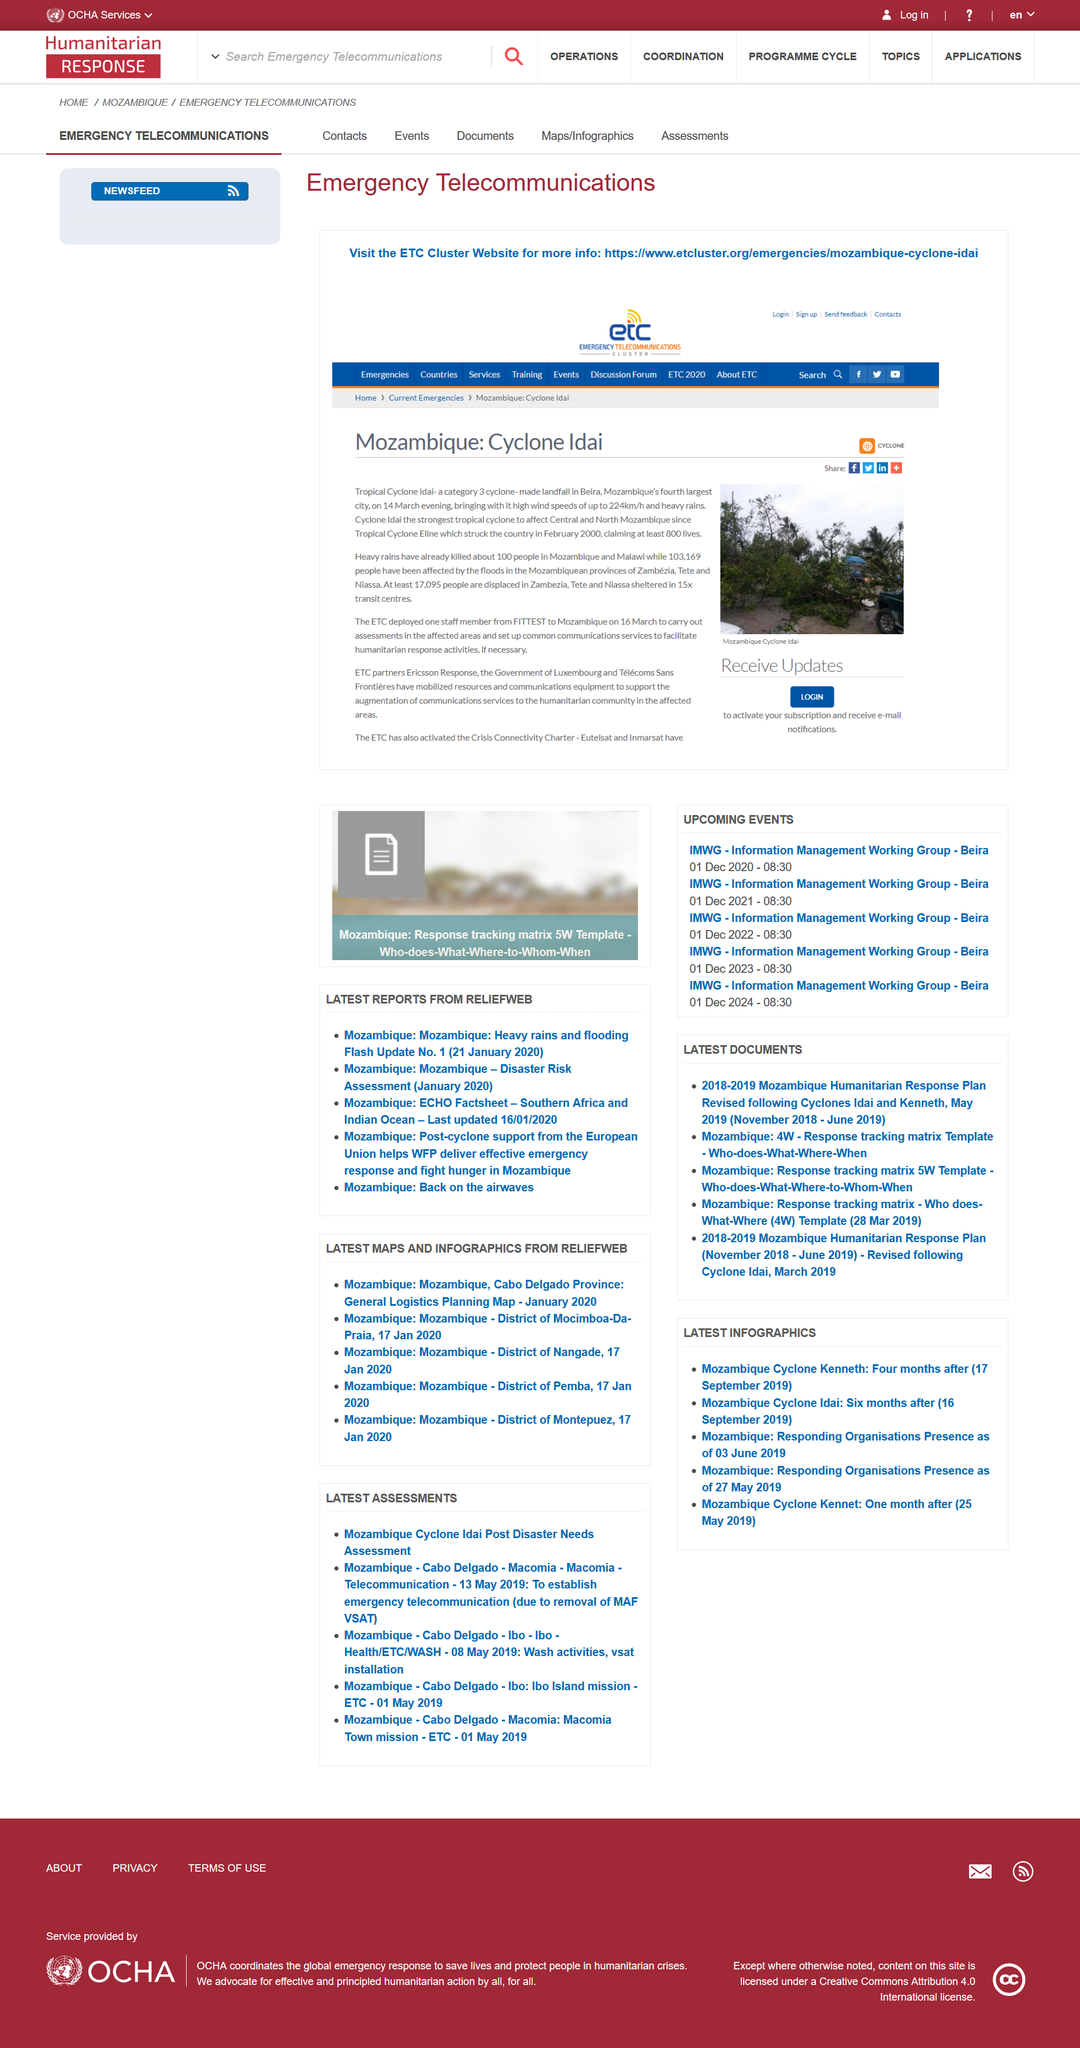Highlight a few significant elements in this photo. Tropical Cyclone Eline made landfall in Mozambique in February 2000. Tropical Cyclone Idai is a category 3 storm, which is a severe category according to the Saffir-Simpson Hurricane Wind Scale. 